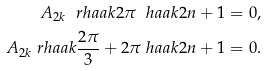<formula> <loc_0><loc_0><loc_500><loc_500>A _ { 2 k } \ r h a a k { 2 \pi \ h a a k { 2 n + 1 } } & = 0 , \\ A _ { 2 k } \ r h a a k { \frac { 2 \pi } { 3 } + 2 \pi \ h a a k { 2 n + 1 } } & = 0 .</formula> 